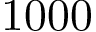<formula> <loc_0><loc_0><loc_500><loc_500>1 0 0 0</formula> 